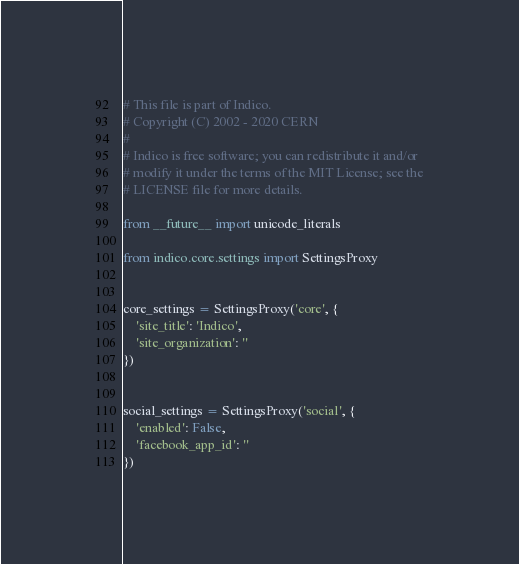Convert code to text. <code><loc_0><loc_0><loc_500><loc_500><_Python_># This file is part of Indico.
# Copyright (C) 2002 - 2020 CERN
#
# Indico is free software; you can redistribute it and/or
# modify it under the terms of the MIT License; see the
# LICENSE file for more details.

from __future__ import unicode_literals

from indico.core.settings import SettingsProxy


core_settings = SettingsProxy('core', {
    'site_title': 'Indico',
    'site_organization': ''
})


social_settings = SettingsProxy('social', {
    'enabled': False,
    'facebook_app_id': ''
})
</code> 